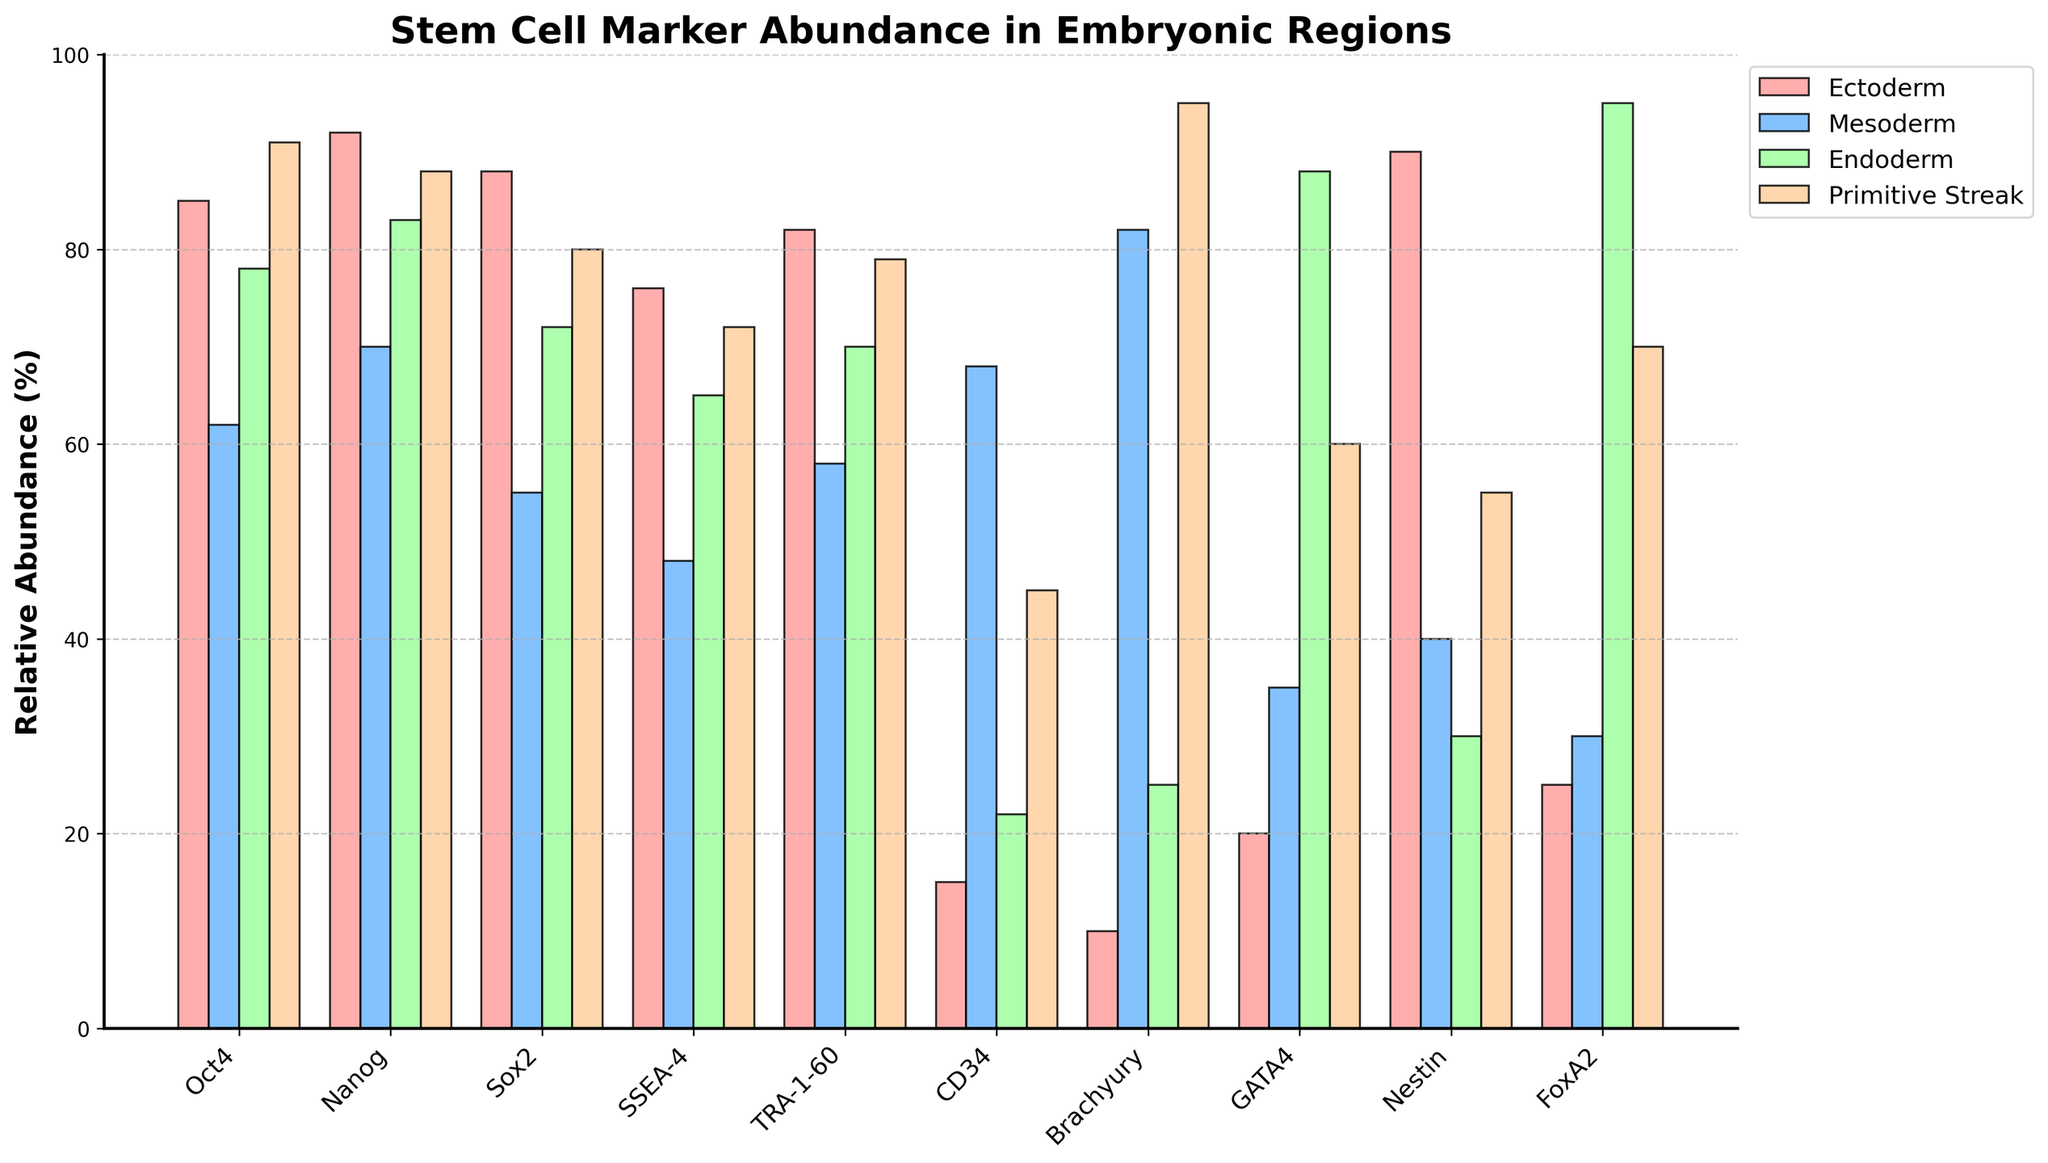Which region has the highest relative abundance of Oct4? To determine this, look for the tallest bar corresponding to Oct4 across all the regions. The highest bar is found in the Primitive Streak region.
Answer: Primitive Streak Which marker has the greatest relative abundance in the Ectoderm region? Identify the highest bar within the Ectoderm section, which is the bar corresponding to Nanog.
Answer: Nanog Which two regions have the closest abundance values for Sox2? Compare the bars for Sox2 across each region and find the two bars with the smallest difference. The Mesoderm (55) and Ectoderm (88) regions have the closest values.
Answer: Mesoderm, Ectoderm What is the range of relative abundance values for GATA4 across the regions? Find the minimum and maximum values for GATA4 across all regions and calculate the range. The minimum is 20 (Ectoderm) and the maximum is 88 (Endoderm), resulting in a range of 88-20 = 68.
Answer: 68 Which marker shows the highest variation in abundance between any two regions? Calculate the difference in relative abundance for each marker across the regions and find the maximum difference. For Brachyury, the difference between Primitive Streak (95) and Ectoderm (10) is the highest, which is 85.
Answer: Brachyury Which region has the most markers with relative abundance below 50%? Count the bars below 50% for each region. Mesoderm has the most markers with values below 50%: Oct4, Sox2, SSEA-4, TRA-1-60, Nestin, and FoxA2.
Answer: Mesoderm Is there any marker with exactly equal abundance in any two regions? Compare the abundance values for each marker across all regions to identify any exact matches. Nestin has equal abundance of 30 in both Endoderm and Mesoderm.
Answer: Nestin What’s the average relative abundance of Nanog across all regions? Add up the relative abundance values for Nanog in all regions and divide by the number of regions. (92 + 70 + 83 + 88) / 4 = 83.25
Answer: 83.25 